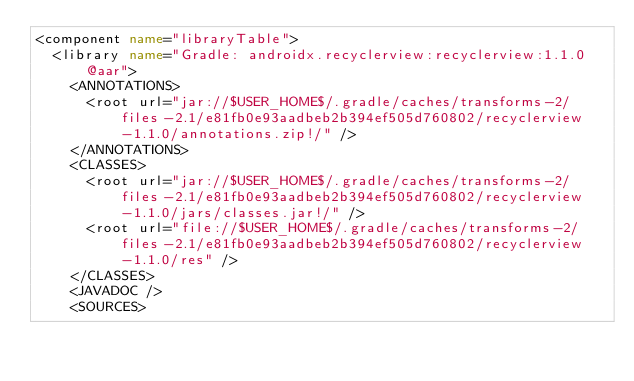<code> <loc_0><loc_0><loc_500><loc_500><_XML_><component name="libraryTable">
  <library name="Gradle: androidx.recyclerview:recyclerview:1.1.0@aar">
    <ANNOTATIONS>
      <root url="jar://$USER_HOME$/.gradle/caches/transforms-2/files-2.1/e81fb0e93aadbeb2b394ef505d760802/recyclerview-1.1.0/annotations.zip!/" />
    </ANNOTATIONS>
    <CLASSES>
      <root url="jar://$USER_HOME$/.gradle/caches/transforms-2/files-2.1/e81fb0e93aadbeb2b394ef505d760802/recyclerview-1.1.0/jars/classes.jar!/" />
      <root url="file://$USER_HOME$/.gradle/caches/transforms-2/files-2.1/e81fb0e93aadbeb2b394ef505d760802/recyclerview-1.1.0/res" />
    </CLASSES>
    <JAVADOC />
    <SOURCES></code> 